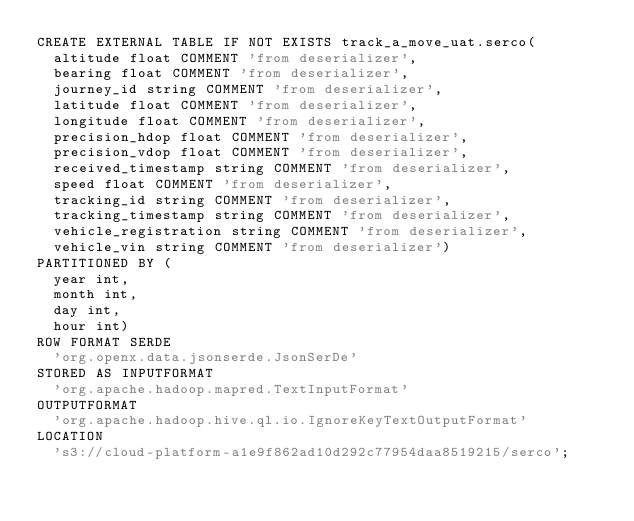Convert code to text. <code><loc_0><loc_0><loc_500><loc_500><_SQL_>CREATE EXTERNAL TABLE IF NOT EXISTS track_a_move_uat.serco(
  altitude float COMMENT 'from deserializer', 
  bearing float COMMENT 'from deserializer', 
  journey_id string COMMENT 'from deserializer', 
  latitude float COMMENT 'from deserializer', 
  longitude float COMMENT 'from deserializer', 
  precision_hdop float COMMENT 'from deserializer', 
  precision_vdop float COMMENT 'from deserializer', 
  received_timestamp string COMMENT 'from deserializer', 
  speed float COMMENT 'from deserializer', 
  tracking_id string COMMENT 'from deserializer', 
  tracking_timestamp string COMMENT 'from deserializer', 
  vehicle_registration string COMMENT 'from deserializer', 
  vehicle_vin string COMMENT 'from deserializer')
PARTITIONED BY ( 
  year int, 
  month int, 
  day int, 
  hour int)
ROW FORMAT SERDE 
  'org.openx.data.jsonserde.JsonSerDe' 
STORED AS INPUTFORMAT 
  'org.apache.hadoop.mapred.TextInputFormat' 
OUTPUTFORMAT 
  'org.apache.hadoop.hive.ql.io.IgnoreKeyTextOutputFormat'
LOCATION
  's3://cloud-platform-a1e9f862ad10d292c77954daa8519215/serco';
</code> 